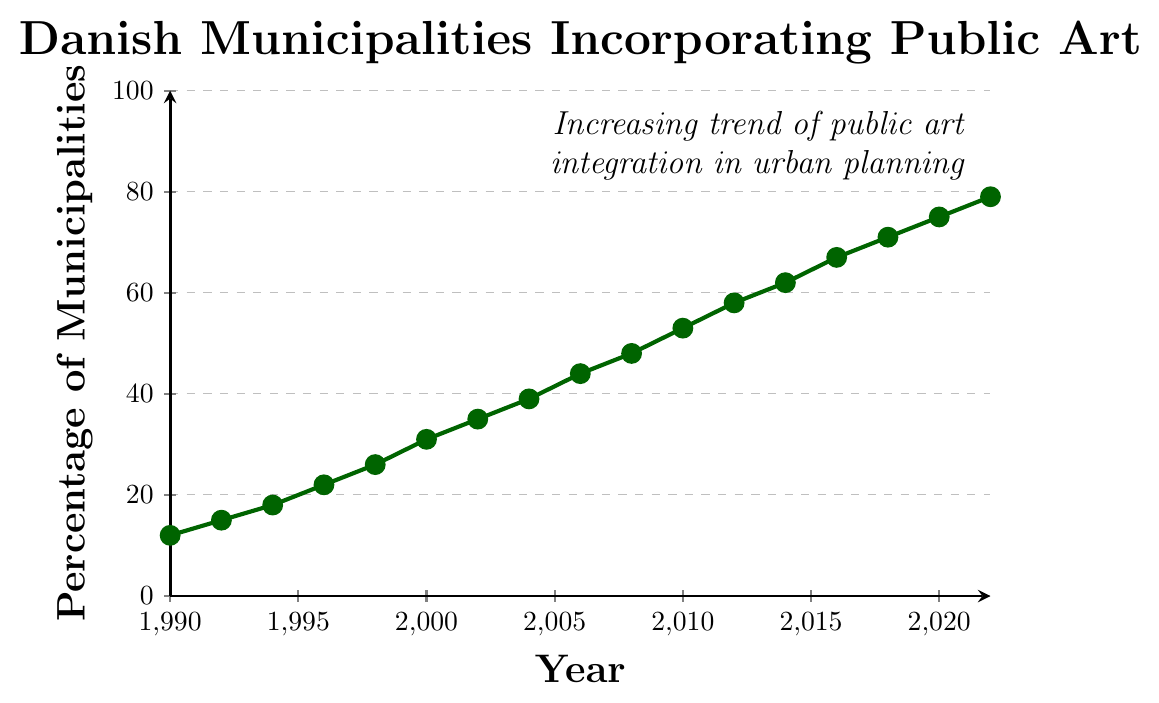What's the percentage of Danish municipalities incorporating public art in urban planning in 2000? The graph shows the percentage each year. Locate the year 2000 on the x-axis and find the corresponding value on the y-axis.
Answer: 31 Between which two consecutive years did the largest increase in the percentage of municipalities occur? To find this, calculate the percentage increase between each pair of consecutive years and identify the largest one. The largest increase occurs between 2010 (53%) and 2012 (58%), which is an increase of 5%.
Answer: 2010 and 2012 What is the average percentage of municipalities incorporating public art from 1990 to 2000? Sum the percentages for the years 1990, 1992, 1994, 1996, 1998, and 2000, then divide by the number of data points: (12 + 15 + 18 + 22 + 26 + 31) / 6 = 124 / 6 ≈ 20.67.
Answer: 20.67 Is there any year where the percentage decrease from the previous year? Observe the trend line in the graph. The graph consistently shows an increasing trend with no decreases between consecutive years.
Answer: No How many years did it take for the percentage to double from its value in 1990? The percentage in 1990 is 12%. Find when it reaches 24% (the double of 12%). In 1998, the percentage is 26%, which is more than double of 12%. So, it took until 1998, which is 8 years from 1990.
Answer: 8 years What color is the line representing the data? The visual attribute of the line in the graph shows it as a specific color, which is dark green.
Answer: Dark green What is the slope of the line between 1996 and 2000? Calculate the slope using the formula (y2 - y1) / (x2 - x1). For the years 1996 and 2000, the corresponding values are 22% and 31%. So, the slope is (31 - 22) / (2000 - 1996) = 9 / 4 = 2.25.
Answer: 2.25 Which year saw the percentage crossing the halfway mark (50%)? Find the point on the graph where the percentage first exceeds 50%. This occurs in 2010, where the percentage is 53%.
Answer: 2010 By how much did the percentage increase from 1994 to 2000? Subtract the percentage in 1994 from that in 2000. The values are 18% and 31%, respectively, so the increase is 31 - 18 = 13.
Answer: 13 What does the text annotation on the graph say about the trend in incorporating public art in urban planning? Locate the text annotation on the graph; it states, "Increasing trend of public art integration in urban planning".
Answer: Increasing trend of public art integration in urban planning 